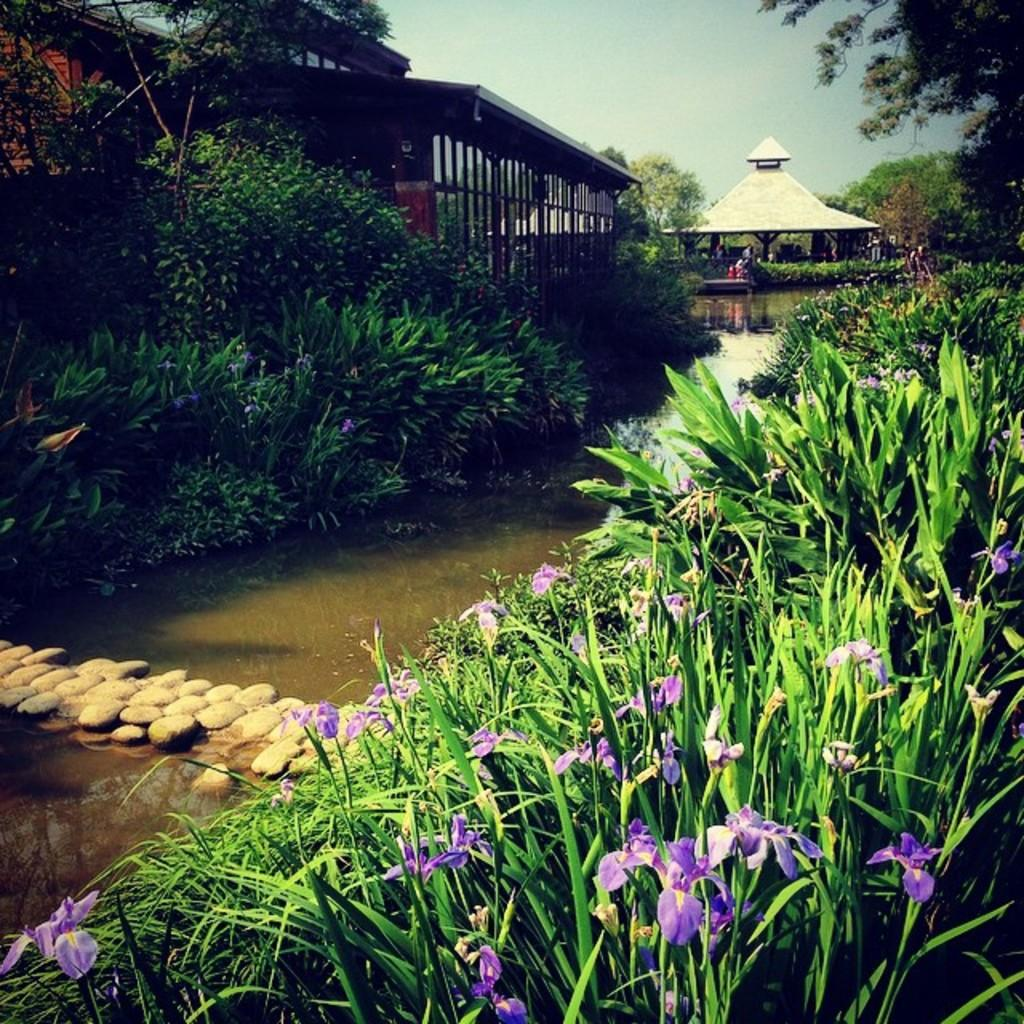What type of structure is visible in the image? There is a house in the image. Are there any other houses in the image? Yes, there is another house beside the first house. What natural feature can be seen in the image? There is a water flow visible in the image. What type of geological feature is present in the image? Rocks are present in the image. What type of plant life is visible in the image? Flowers are associated with plants in the image, and there are also trees present. What type of flavor can be detected in the drum in the image? There is no drum present in the image, so it is not possible to determine any flavors associated with it. 